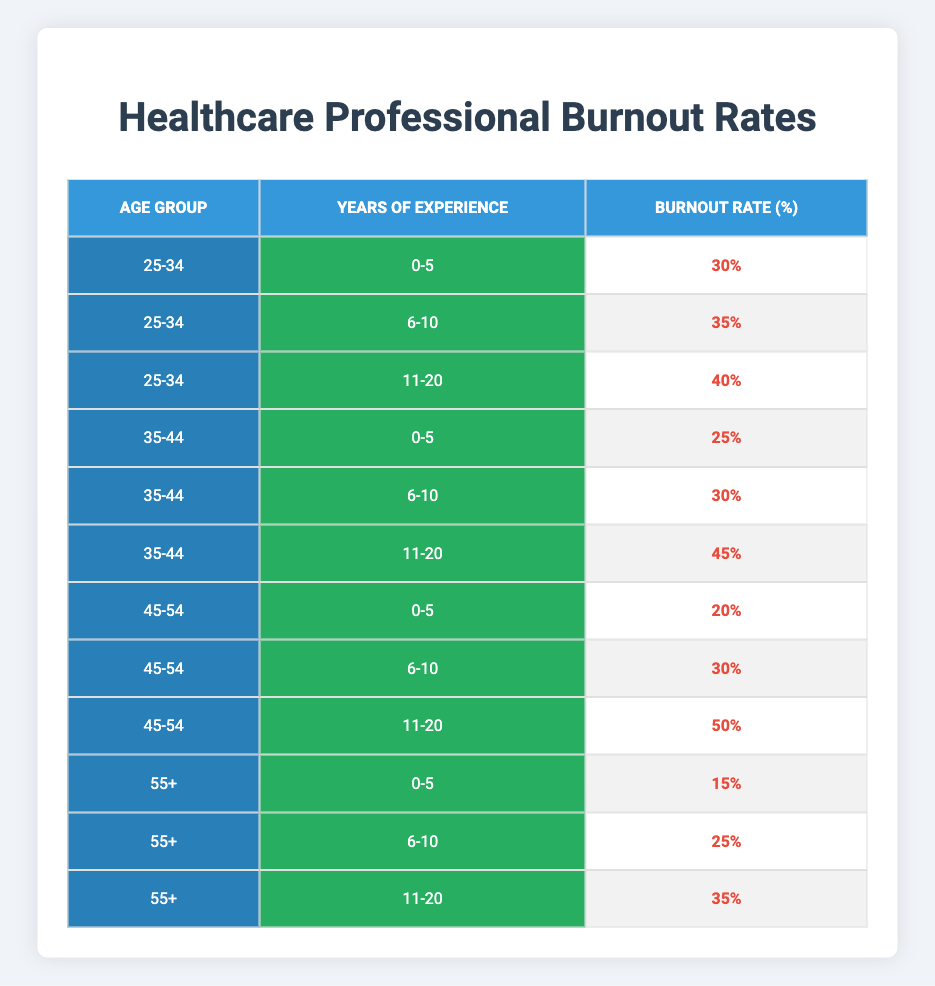What is the burnout rate for healthcare professionals aged 25-34 with 0-5 years of experience? The table shows that the burnout rate for the age group 25-34 and the experience category 0-5 years is 30%.
Answer: 30% What is the burnout rate for healthcare professionals aged 45-54 with 11-20 years of experience? According to the table, the burnout rate for the age group 45-54 and the experience category 11-20 years is 50%.
Answer: 50% Is the burnout rate higher for the age group 35-44 with 11-20 years of experience compared to the age group 25-34 with the same level of experience? The burnout rate for age group 35-44 with 11-20 years of experience is 45%, while for age group 25-34 with the same experience, it is 40%. Therefore, it is higher for the 35-44 age group.
Answer: Yes What is the average burnout rate for healthcare professionals aged 55+ across all experience levels? The burnout rates for the age group 55+ are 15%, 25%, and 35%. To find the average, we sum these rates: 15 + 25 + 35 = 75, and then divide by the number of data points, which is 3. Thus, the average is 75 / 3 = 25%.
Answer: 25% Which age group has the lowest burnout rate for healthcare professionals with 0-5 years of experience? From the table, the age group 55+ has the lowest burnout rate with 15% among those with 0-5 years of experience, compared to other age groups: 25-34 (30%) and 35-44 (25%).
Answer: 55+ (15%) What can be said about the trend of burnout rates as years of experience increase for the age group 45-54? The burnout rates for age group 45-54 with increasing years of experience are 20% (0-5 years), 30% (6-10 years), and 50% (11-20 years). This indicates a clear upward trend in burnout rates as years of experience increase.
Answer: Upward trend Is it true that healthcare professionals with 6-10 years of experience have consistently higher burnout rates as compared to those with 0-5 years across all age groups? The data indicates that for 0-5 years of experience the rates are 30% (25-34), 25% (35-44), and 20% (45-54), while for 6-10 years the rates are 35% (25-34), 30% (35-44), and 30% (45-54). In every case, the 6-10 years rates are indeed higher.
Answer: Yes What is the total burnout rate for the age group 25-34 across all years of experience? The burnout rates for age group 25-34 are 30% (0-5 years), 35% (6-10 years), and 40% (11-20 years). Summing these up gives 30 + 35 + 40 = 105%. The total burnout rate for this age group is thus 105%.
Answer: 105% What is the difference in burnout rates between the age group 35-44 with 11-20 years and the age group 45-54 with the same experience? From the data, the burnout rate for age group 35-44 with 11-20 years is 45%, while for age group 45-54, it is 50%. Therefore, the difference is 50% - 45% = 5%.
Answer: 5% 